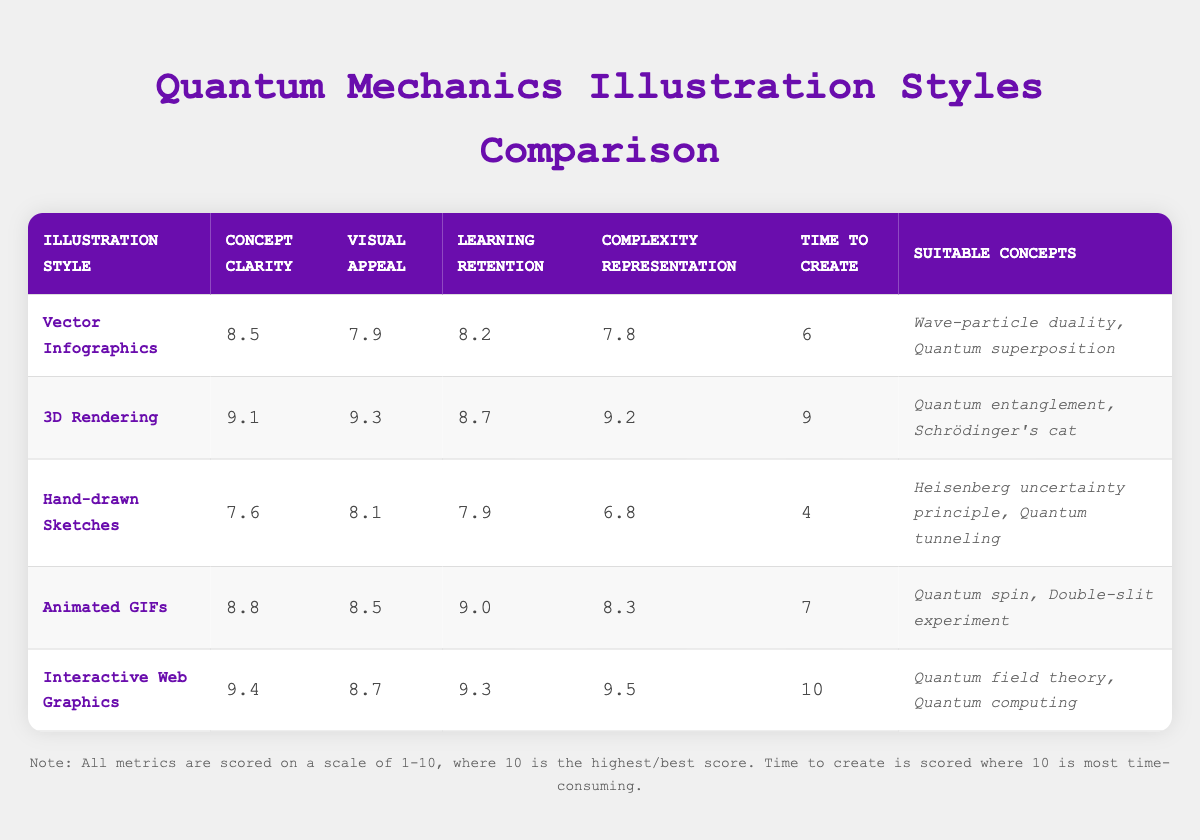What is the concept clarity score of 3D Rendering? The table shows the concept clarity score for 3D Rendering listed under the "Concept Clarity" column. The score is 9.1.
Answer: 9.1 Which illustration style has the highest learning retention score? To find the highest learning retention score, we compare the scores in the "Learning Retention" column. The highest score is 9.3, which belongs to Interactive Web Graphics.
Answer: Interactive Web Graphics Is Hand-drawn Sketches suitable for explaining Quantum field theory? The "Suitable Concepts" column for Hand-drawn Sketches lists concepts that include Heisenberg uncertainty principle and Quantum tunneling, but does not include Quantum field theory. Therefore, the answer is no.
Answer: No What is the average visual appeal score of Vector Infographics and Animated GIFs? The visual appeal score for Vector Infographics is 7.9 and for Animated GIFs is 8.5. To find the average, we sum these two scores: 7.9 + 8.5 = 16.4, and then divide by 2, which gives 16.4 / 2 = 8.2.
Answer: 8.2 Which illustration style has the lowest complexity representation score? Reviewing the "Complexity Representation" column, Hand-drawn Sketches has the lowest score of 6.8 when compared to other styles.
Answer: Hand-drawn Sketches What is the difference in time to create between 3D Rendering and Animated GIFs? The time to create for 3D Rendering is 9 and for Animated GIFs is 7. The difference is calculated as 9 - 7 = 2.
Answer: 2 Which two illustration styles have scores above 8 for both concept clarity and learning retention? We compare the scores for concept clarity and learning retention beyond 8. The styles with scores above 8 in both categories are 3D Rendering (9.1 clarity, 8.7 retention) and Interactive Web Graphics (9.4 clarity, 9.3 retention).
Answer: 3D Rendering, Interactive Web Graphics Is it true that Vector Infographics can effectively represent the complexity of Quantum superposition? Looking at both "Suitable Concepts" and the "Complexity Representation" score of Vector Infographics, represented as 7.8. Though it is suitable for Quantum superposition, a score of 7.8 indicates moderate effectiveness in representing complexity. Thus, the answer is somewhat subjective and can be considered true but limited.
Answer: Yes 